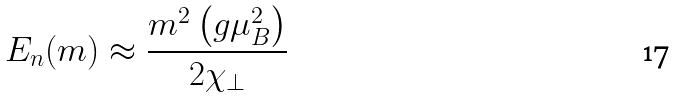<formula> <loc_0><loc_0><loc_500><loc_500>E _ { n } ( m ) \approx \frac { m ^ { 2 } \left ( g \mu _ { B } ^ { 2 } \right ) } { 2 \chi _ { \bot } }</formula> 